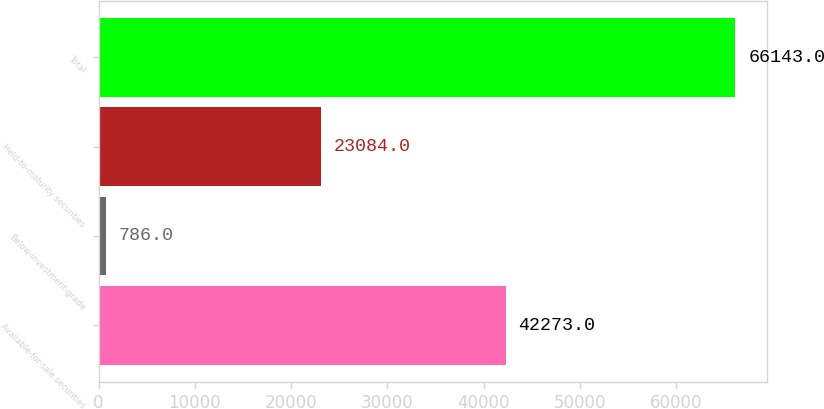Convert chart to OTSL. <chart><loc_0><loc_0><loc_500><loc_500><bar_chart><fcel>Available-for-sale securities<fcel>Below-investment-grade<fcel>Held-to-maturity securities<fcel>Total<nl><fcel>42273<fcel>786<fcel>23084<fcel>66143<nl></chart> 